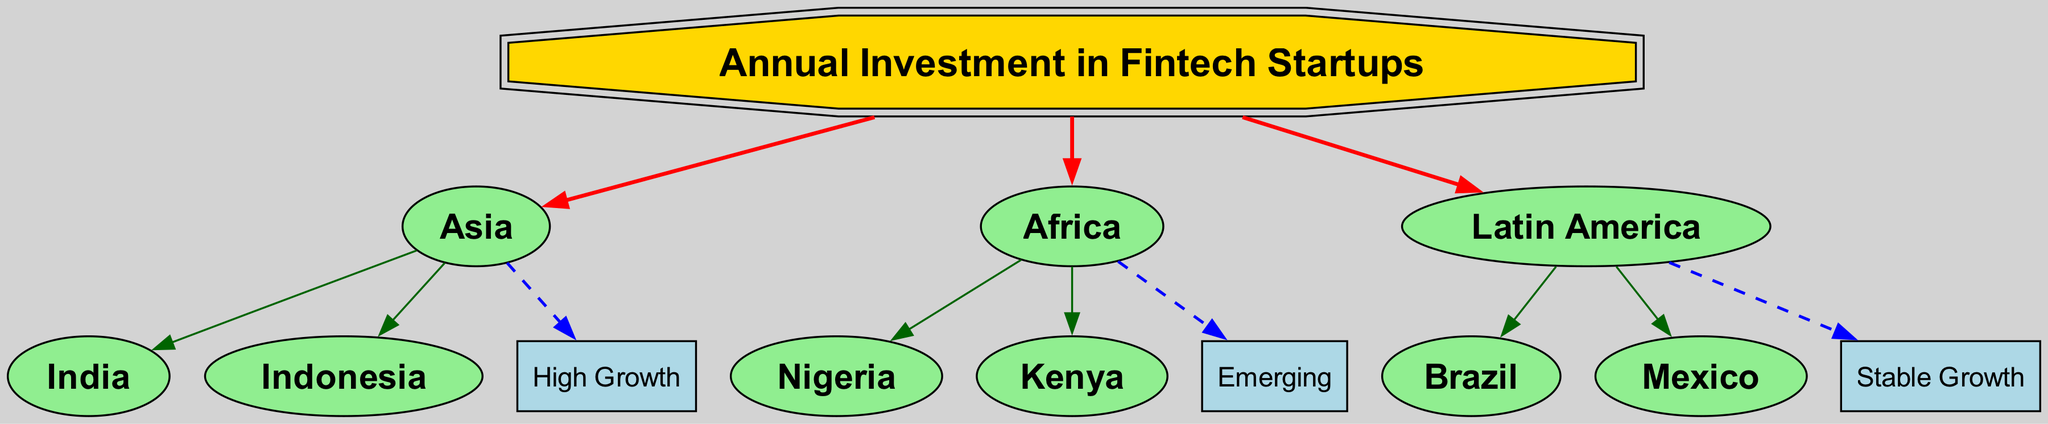What is the central theme of the diagram? The core node labeled "Annual Investment in Fintech Startups" represents the central theme of the diagram, connecting various regions and trends related to fintech investments.
Answer: Annual Investment in Fintech Startups How many regions are represented in the diagram? By counting the edges that connect from the core node to the three regions (Asia, Africa, Latin America), we find there are three distinct regions represented in the diagram.
Answer: 3 Which region is associated with the trend "High Growth"? The edge from "Asia" leads to "High Growth," which identifies the region associated with this trend.
Answer: Asia Name one country from the Africa region highlighted in the diagram. The diagram shows Nigeria and Kenya as countries in the Africa region. For this question, mentioning either qualifies as a valid answer.
Answer: Nigeria What type of trend is associated with Latin America? The edge connecting "Latin America" to "Stable Growth" indicates that this is the trend specifically associated with Latin America in the diagram.
Answer: Stable Growth Which region has countries identified as having an "Emerging" trend? The edge from "Africa" points to "Emerging," indicating that this trend applies to the countries listed under the Africa region, such as Nigeria and Kenya.
Answer: Africa What color represents the trend nodes in the diagram? The trend nodes (High Growth, Emerging, Stable Growth) are all depicted in light blue, which is a distinctive aspect of their visual representation.
Answer: Light blue How many countries are listed under Asia in the diagram? By observing the connections from the "Asia" node to its two connecting countries (India and Indonesia), we conclude that two countries are listed under this region.
Answer: 2 What is the relationship between "Africa" and "Kenya"? The edge connecting "Africa" to "Kenya" indicates a direct relationship, signifying that Kenya is one of the countries within the Africa region.
Answer: Direct relationship 